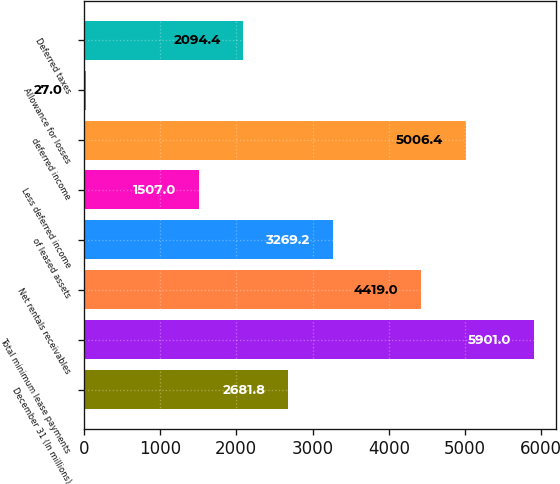Convert chart to OTSL. <chart><loc_0><loc_0><loc_500><loc_500><bar_chart><fcel>December 31 (In millions)<fcel>Total minimum lease payments<fcel>Net rentals receivables<fcel>of leased assets<fcel>Less deferred income<fcel>deferred income<fcel>Allowance for losses<fcel>Deferred taxes<nl><fcel>2681.8<fcel>5901<fcel>4419<fcel>3269.2<fcel>1507<fcel>5006.4<fcel>27<fcel>2094.4<nl></chart> 